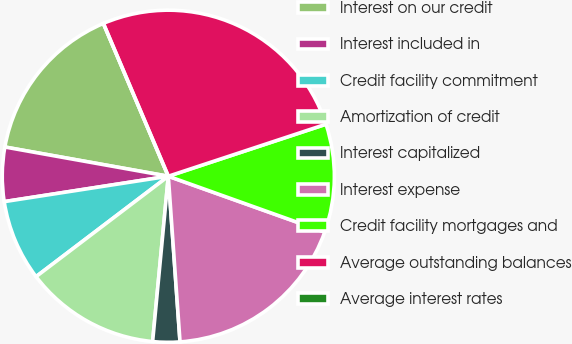<chart> <loc_0><loc_0><loc_500><loc_500><pie_chart><fcel>Interest on our credit<fcel>Interest included in<fcel>Credit facility commitment<fcel>Amortization of credit<fcel>Interest capitalized<fcel>Interest expense<fcel>Credit facility mortgages and<fcel>Average outstanding balances<fcel>Average interest rates<nl><fcel>15.79%<fcel>5.26%<fcel>7.89%<fcel>13.16%<fcel>2.63%<fcel>18.42%<fcel>10.53%<fcel>26.32%<fcel>0.0%<nl></chart> 